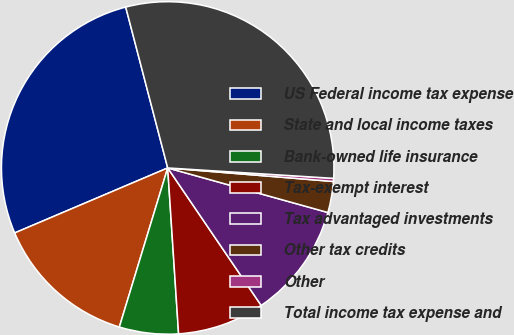Convert chart to OTSL. <chart><loc_0><loc_0><loc_500><loc_500><pie_chart><fcel>US Federal income tax expense<fcel>State and local income taxes<fcel>Bank-owned life insurance<fcel>Tax-exempt interest<fcel>Tax advantaged investments<fcel>Other tax credits<fcel>Other<fcel>Total income tax expense and<nl><fcel>27.33%<fcel>13.91%<fcel>5.74%<fcel>8.46%<fcel>11.18%<fcel>3.02%<fcel>0.3%<fcel>30.06%<nl></chart> 